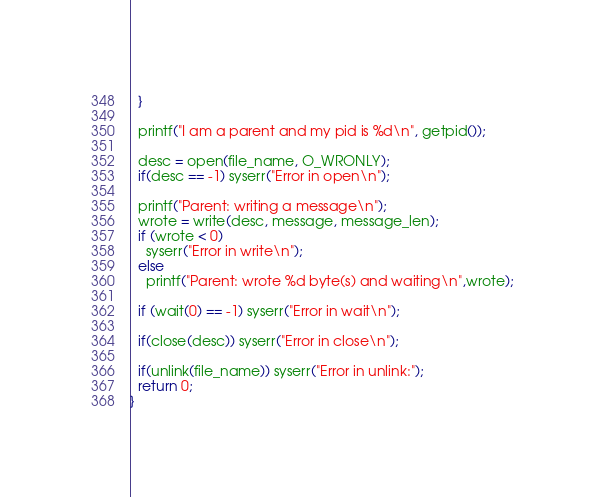<code> <loc_0><loc_0><loc_500><loc_500><_C_>  }

  printf("I am a parent and my pid is %d\n", getpid());
    
  desc = open(file_name, O_WRONLY);
  if(desc == -1) syserr("Error in open\n"); 
  
  printf("Parent: writing a message\n");
  wrote = write(desc, message, message_len);
  if (wrote < 0) 
    syserr("Error in write\n");
  else
    printf("Parent: wrote %d byte(s) and waiting\n",wrote);
    
  if (wait(0) == -1) syserr("Error in wait\n");
  
  if(close(desc)) syserr("Error in close\n");
  
  if(unlink(file_name)) syserr("Error in unlink:");
  return 0;
}
</code> 